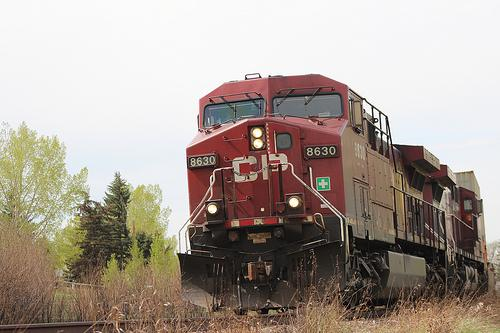Tell a brief story about the main subject and its surroundings in the photograph. A red train adorned with CP letters and two prominent front windows journeys down the tracks, framed by an enchanting landscape of foliage and a sky peppered with white clouds. Give a short account of the main object and its background in the picture. A red train with CP letters and two front windows travels down the tracks, surrounded by lush vegetation and a sky full of clouds. Provide an overview of the image, focusing on the central object and its environment. A bright red train with distinctive CP letters and two windows travels down railroad tracks, surrounded by an idyllic setting of green trees and a cloudy sky. Describe the focal point of the image and what it is doing. A red train featuring CP letters and two front windows is making its way down the railroad tracks, with trees and clouds as its backdrop. Elaborate on the main subject of the image and its particular features. A red train with CP letters on its front and two windows is traveling down the tracks surrounded by green trees and a sky filled with white clouds. Express the central theme of the image, including the main object and its environment. A crimson train embarks on a journey down the tracks, flanked by verdant trees and a backdrop of a serene, cloud-dotted sky. Describe the primary subject and its context within the image. A vibrant red train adorned with CP letters and dual front windows moves along tracks in a green, tree-filled area beneath a cloud-laden sky. Mention the primary focus of the image and its activity. A red train is traveling down the tracks with two front windows and CP letters on it. Narrate the primary object and some details in the picture. A red train with two front windows and CP letters passes through a picturesque landscape, with lush green trees and a sky sprinkled with white clouds. Provide a brief description of the main object in the image and its surroundings. The image shows a red train on the tracks, surrounded by trees, with clouds in the blue sky. 